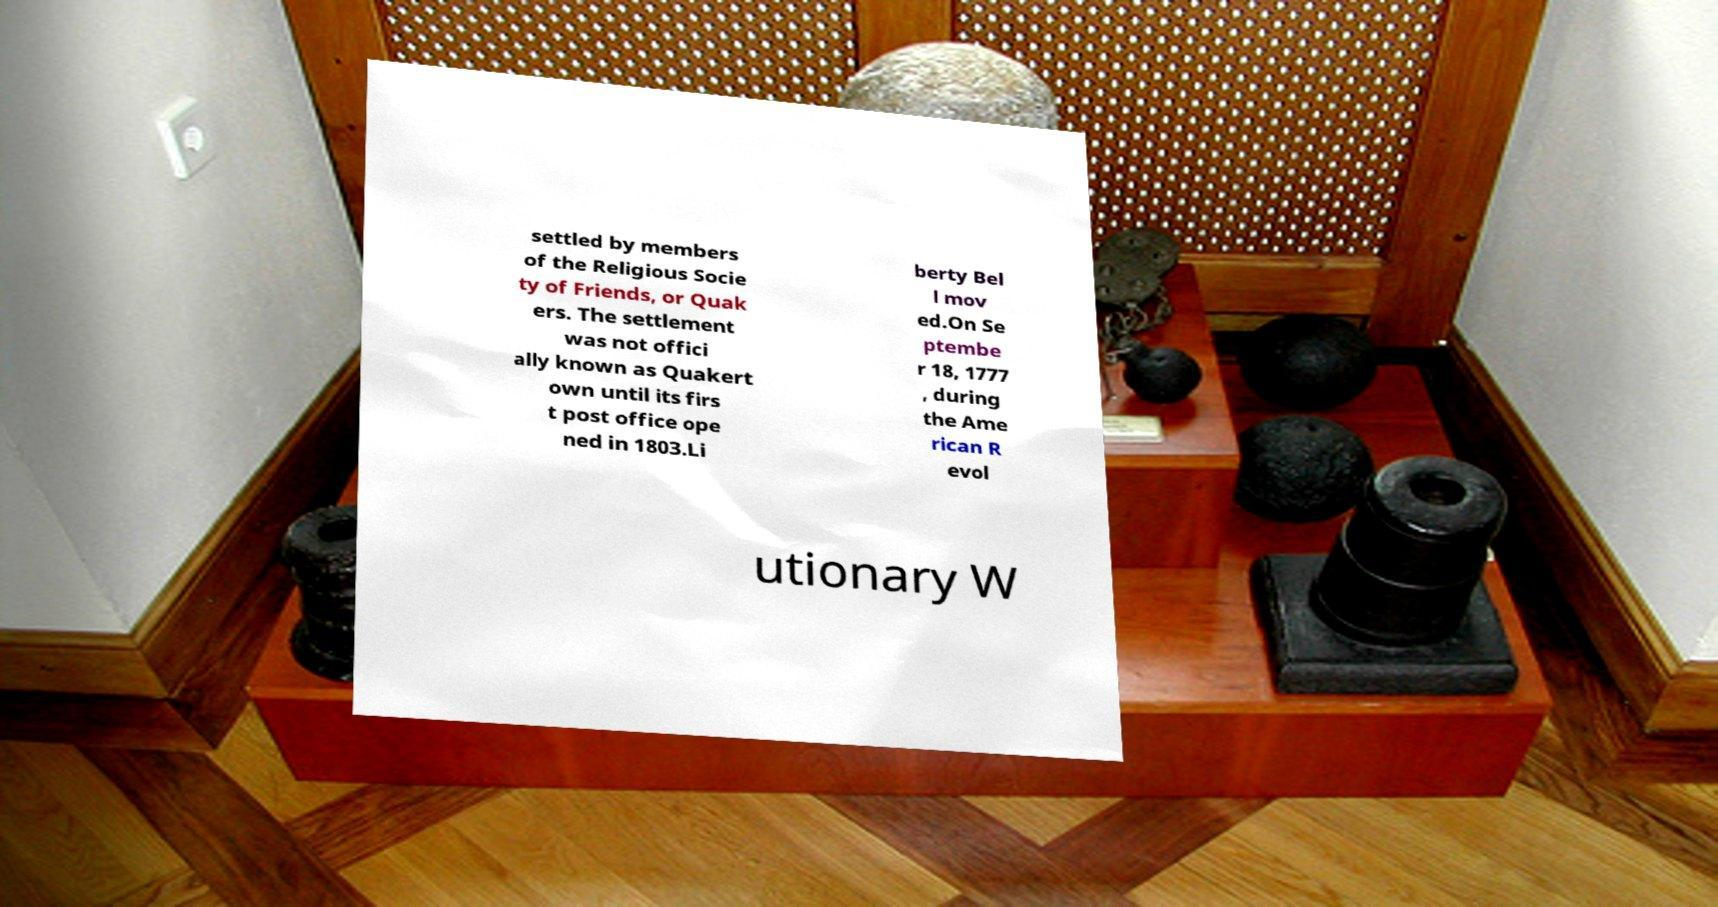Can you accurately transcribe the text from the provided image for me? settled by members of the Religious Socie ty of Friends, or Quak ers. The settlement was not offici ally known as Quakert own until its firs t post office ope ned in 1803.Li berty Bel l mov ed.On Se ptembe r 18, 1777 , during the Ame rican R evol utionary W 